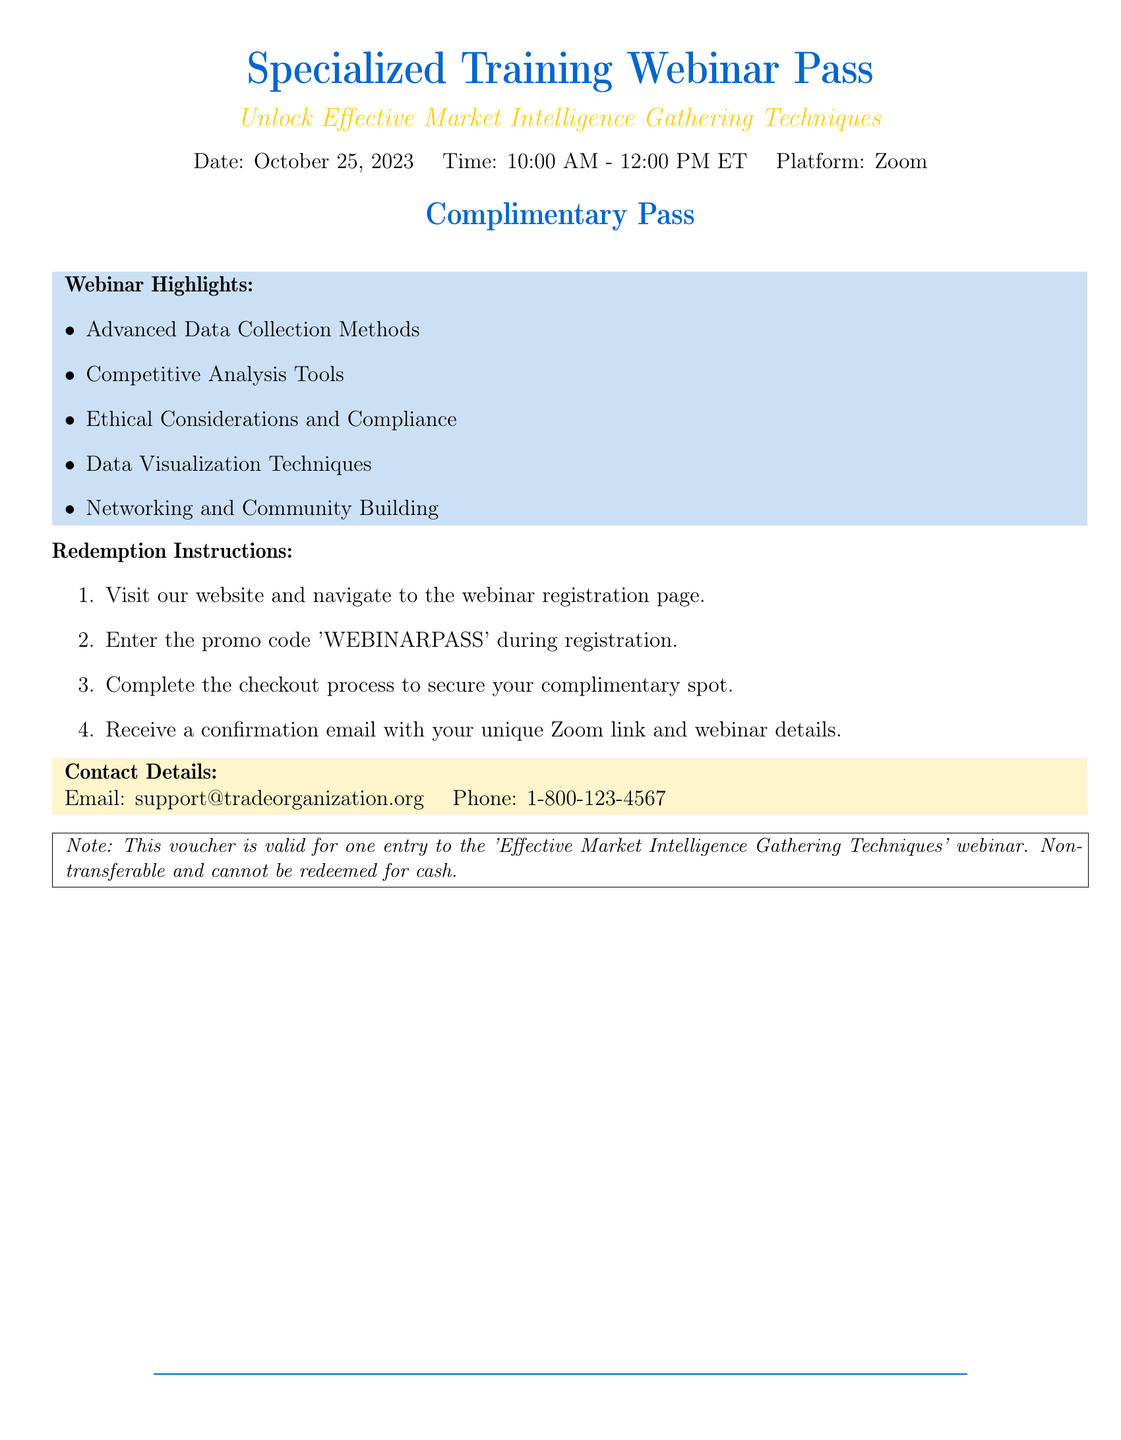What is the date of the webinar? The date is mentioned in the document as October 25, 2023.
Answer: October 25, 2023 What time does the webinar start? The document specifies the start time of the webinar as 10:00 AM ET.
Answer: 10:00 AM What is the promo code for registration? The promo code provided for registration in the document is 'WEBINARPASS'.
Answer: WEBINARPASS What is one of the webinar highlights? The document lists several highlights; one is "Ethical Considerations and Compliance."
Answer: Ethical Considerations and Compliance What platform will the webinar be hosted on? The document states that the platform for the webinar is Zoom.
Answer: Zoom How many steps are there in the redemption instructions? The document outlines the redemption process in four steps, indicating the number of steps.
Answer: 4 Is the voucher transferable? The document explicitly states that the voucher is non-transferable.
Answer: Non-transferable What is the contact email provided in the document? The document lists the contact email as support@tradeorganization.org.
Answer: support@tradeorganization.org What does the voucher note say regarding cash redemption? The note in the document mentions that the voucher cannot be redeemed for cash.
Answer: Cannot be redeemed for cash 